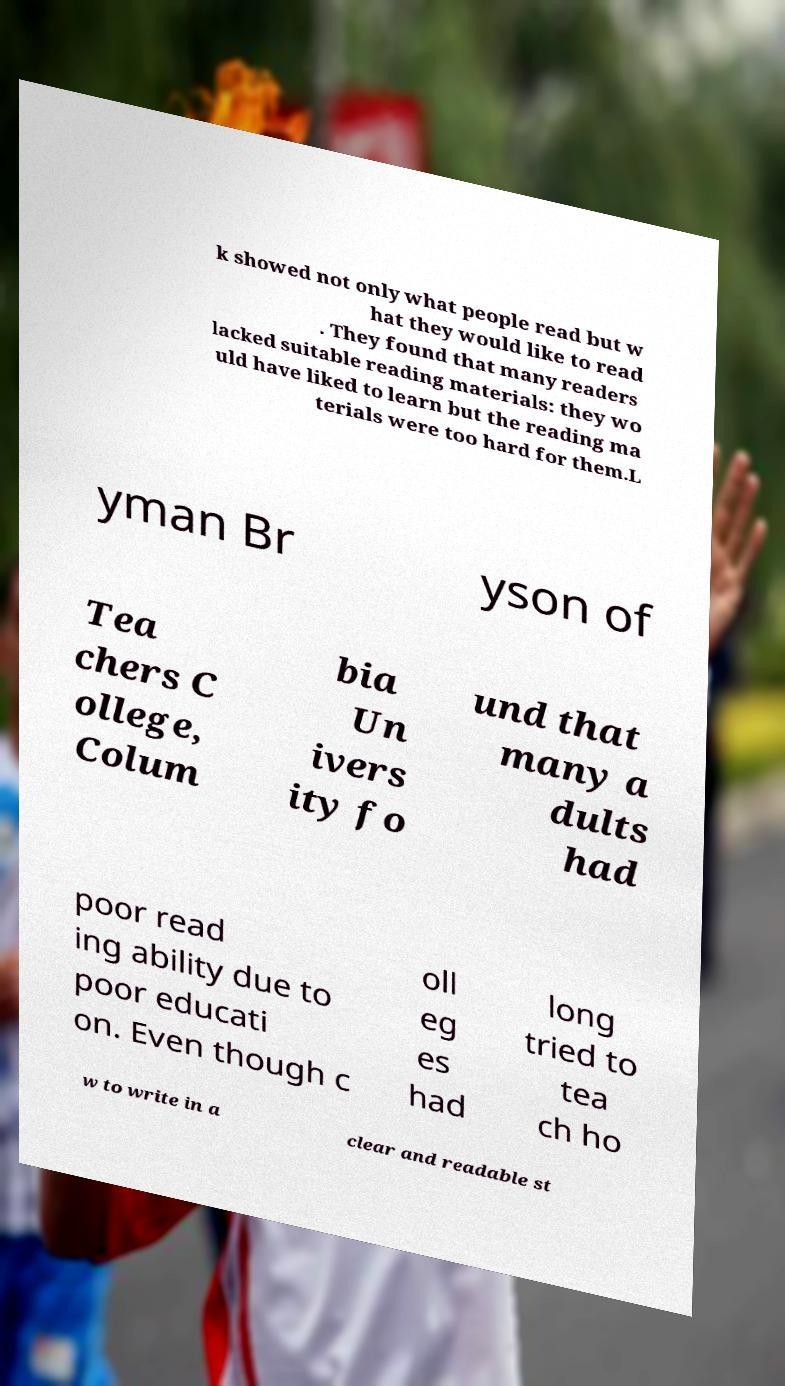There's text embedded in this image that I need extracted. Can you transcribe it verbatim? k showed not only what people read but w hat they would like to read . They found that many readers lacked suitable reading materials: they wo uld have liked to learn but the reading ma terials were too hard for them.L yman Br yson of Tea chers C ollege, Colum bia Un ivers ity fo und that many a dults had poor read ing ability due to poor educati on. Even though c oll eg es had long tried to tea ch ho w to write in a clear and readable st 